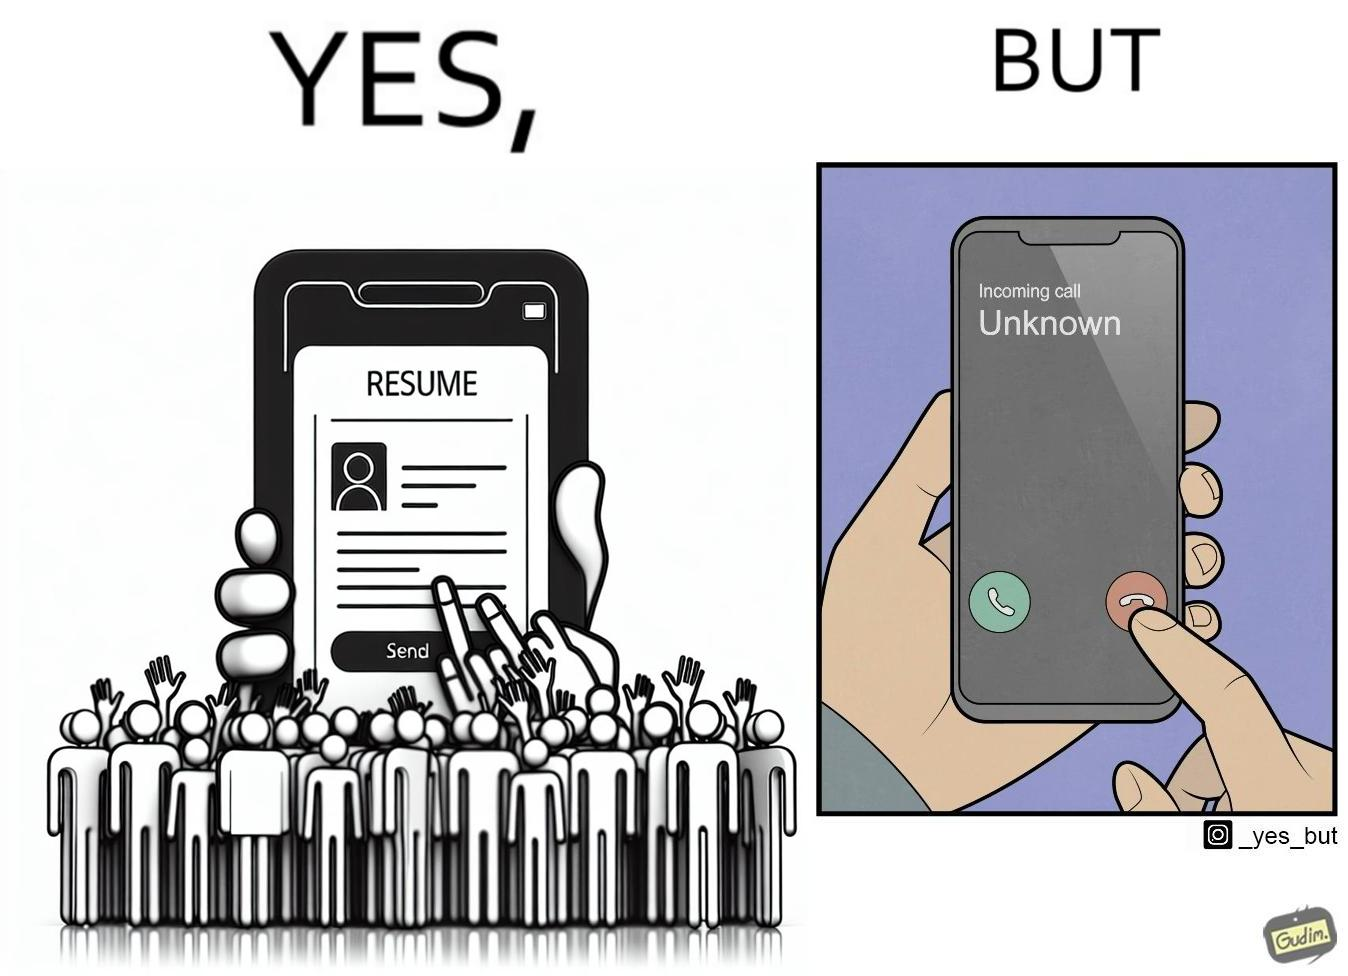Explain the humor or irony in this image. The image is ironic, because on the left image the person is sending their resume to someone and on the right they are rejecting the unknown calls which might be some offer calls  or the person who sent the resume maybe tired of the spam calls after sending the resume which he sent seeking some new oppurtunities 